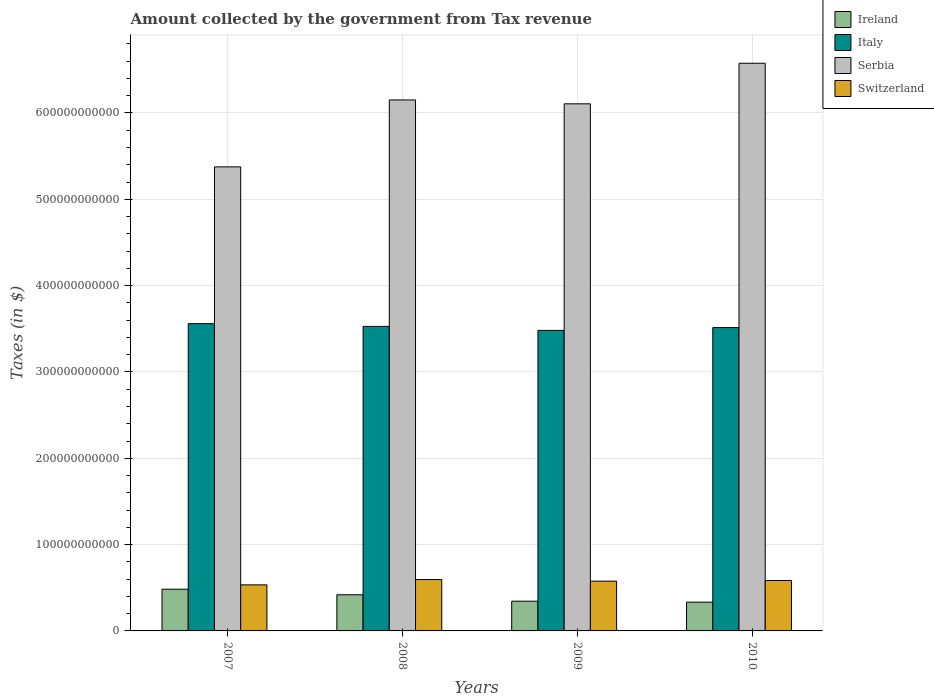How many different coloured bars are there?
Your answer should be very brief. 4. How many groups of bars are there?
Ensure brevity in your answer.  4. How many bars are there on the 4th tick from the left?
Provide a short and direct response. 4. How many bars are there on the 1st tick from the right?
Give a very brief answer. 4. What is the label of the 2nd group of bars from the left?
Your answer should be compact. 2008. What is the amount collected by the government from tax revenue in Switzerland in 2007?
Your answer should be compact. 5.34e+1. Across all years, what is the maximum amount collected by the government from tax revenue in Serbia?
Ensure brevity in your answer.  6.58e+11. Across all years, what is the minimum amount collected by the government from tax revenue in Serbia?
Your answer should be very brief. 5.38e+11. What is the total amount collected by the government from tax revenue in Switzerland in the graph?
Make the answer very short. 2.29e+11. What is the difference between the amount collected by the government from tax revenue in Italy in 2007 and that in 2009?
Keep it short and to the point. 7.78e+09. What is the difference between the amount collected by the government from tax revenue in Switzerland in 2008 and the amount collected by the government from tax revenue in Italy in 2009?
Your answer should be compact. -2.89e+11. What is the average amount collected by the government from tax revenue in Switzerland per year?
Your answer should be compact. 5.72e+1. In the year 2008, what is the difference between the amount collected by the government from tax revenue in Serbia and amount collected by the government from tax revenue in Italy?
Your answer should be very brief. 2.62e+11. In how many years, is the amount collected by the government from tax revenue in Switzerland greater than 380000000000 $?
Provide a succinct answer. 0. What is the ratio of the amount collected by the government from tax revenue in Switzerland in 2008 to that in 2010?
Ensure brevity in your answer.  1.02. What is the difference between the highest and the second highest amount collected by the government from tax revenue in Italy?
Ensure brevity in your answer.  3.18e+09. What is the difference between the highest and the lowest amount collected by the government from tax revenue in Serbia?
Provide a short and direct response. 1.20e+11. In how many years, is the amount collected by the government from tax revenue in Ireland greater than the average amount collected by the government from tax revenue in Ireland taken over all years?
Provide a short and direct response. 2. What does the 2nd bar from the left in 2007 represents?
Offer a very short reply. Italy. What does the 1st bar from the right in 2008 represents?
Make the answer very short. Switzerland. How many bars are there?
Give a very brief answer. 16. How many years are there in the graph?
Your answer should be very brief. 4. What is the difference between two consecutive major ticks on the Y-axis?
Provide a short and direct response. 1.00e+11. Where does the legend appear in the graph?
Ensure brevity in your answer.  Top right. What is the title of the graph?
Give a very brief answer. Amount collected by the government from Tax revenue. What is the label or title of the X-axis?
Your response must be concise. Years. What is the label or title of the Y-axis?
Your response must be concise. Taxes (in $). What is the Taxes (in $) of Ireland in 2007?
Your answer should be compact. 4.83e+1. What is the Taxes (in $) of Italy in 2007?
Keep it short and to the point. 3.56e+11. What is the Taxes (in $) in Serbia in 2007?
Make the answer very short. 5.38e+11. What is the Taxes (in $) of Switzerland in 2007?
Keep it short and to the point. 5.34e+1. What is the Taxes (in $) in Ireland in 2008?
Offer a terse response. 4.19e+1. What is the Taxes (in $) of Italy in 2008?
Ensure brevity in your answer.  3.53e+11. What is the Taxes (in $) of Serbia in 2008?
Provide a short and direct response. 6.15e+11. What is the Taxes (in $) of Switzerland in 2008?
Provide a succinct answer. 5.95e+1. What is the Taxes (in $) of Ireland in 2009?
Provide a short and direct response. 3.45e+1. What is the Taxes (in $) in Italy in 2009?
Make the answer very short. 3.48e+11. What is the Taxes (in $) of Serbia in 2009?
Make the answer very short. 6.11e+11. What is the Taxes (in $) of Switzerland in 2009?
Provide a succinct answer. 5.77e+1. What is the Taxes (in $) of Ireland in 2010?
Provide a short and direct response. 3.33e+1. What is the Taxes (in $) of Italy in 2010?
Provide a succinct answer. 3.51e+11. What is the Taxes (in $) in Serbia in 2010?
Your response must be concise. 6.58e+11. What is the Taxes (in $) in Switzerland in 2010?
Offer a terse response. 5.84e+1. Across all years, what is the maximum Taxes (in $) of Ireland?
Provide a short and direct response. 4.83e+1. Across all years, what is the maximum Taxes (in $) in Italy?
Your answer should be very brief. 3.56e+11. Across all years, what is the maximum Taxes (in $) in Serbia?
Offer a very short reply. 6.58e+11. Across all years, what is the maximum Taxes (in $) in Switzerland?
Provide a short and direct response. 5.95e+1. Across all years, what is the minimum Taxes (in $) in Ireland?
Your response must be concise. 3.33e+1. Across all years, what is the minimum Taxes (in $) in Italy?
Your answer should be compact. 3.48e+11. Across all years, what is the minimum Taxes (in $) in Serbia?
Make the answer very short. 5.38e+11. Across all years, what is the minimum Taxes (in $) in Switzerland?
Your answer should be very brief. 5.34e+1. What is the total Taxes (in $) of Ireland in the graph?
Make the answer very short. 1.58e+11. What is the total Taxes (in $) of Italy in the graph?
Keep it short and to the point. 1.41e+12. What is the total Taxes (in $) in Serbia in the graph?
Your answer should be compact. 2.42e+12. What is the total Taxes (in $) of Switzerland in the graph?
Give a very brief answer. 2.29e+11. What is the difference between the Taxes (in $) in Ireland in 2007 and that in 2008?
Keep it short and to the point. 6.43e+09. What is the difference between the Taxes (in $) of Italy in 2007 and that in 2008?
Ensure brevity in your answer.  3.18e+09. What is the difference between the Taxes (in $) of Serbia in 2007 and that in 2008?
Offer a very short reply. -7.75e+1. What is the difference between the Taxes (in $) of Switzerland in 2007 and that in 2008?
Your answer should be compact. -6.15e+09. What is the difference between the Taxes (in $) of Ireland in 2007 and that in 2009?
Your answer should be very brief. 1.39e+1. What is the difference between the Taxes (in $) in Italy in 2007 and that in 2009?
Offer a terse response. 7.78e+09. What is the difference between the Taxes (in $) in Serbia in 2007 and that in 2009?
Your answer should be compact. -7.30e+1. What is the difference between the Taxes (in $) of Switzerland in 2007 and that in 2009?
Your answer should be compact. -4.30e+09. What is the difference between the Taxes (in $) of Ireland in 2007 and that in 2010?
Your answer should be compact. 1.50e+1. What is the difference between the Taxes (in $) in Italy in 2007 and that in 2010?
Your answer should be very brief. 4.54e+09. What is the difference between the Taxes (in $) in Serbia in 2007 and that in 2010?
Make the answer very short. -1.20e+11. What is the difference between the Taxes (in $) in Switzerland in 2007 and that in 2010?
Offer a very short reply. -5.05e+09. What is the difference between the Taxes (in $) in Ireland in 2008 and that in 2009?
Provide a succinct answer. 7.44e+09. What is the difference between the Taxes (in $) of Italy in 2008 and that in 2009?
Your answer should be compact. 4.60e+09. What is the difference between the Taxes (in $) of Serbia in 2008 and that in 2009?
Your answer should be compact. 4.50e+09. What is the difference between the Taxes (in $) of Switzerland in 2008 and that in 2009?
Provide a succinct answer. 1.85e+09. What is the difference between the Taxes (in $) of Ireland in 2008 and that in 2010?
Offer a terse response. 8.56e+09. What is the difference between the Taxes (in $) of Italy in 2008 and that in 2010?
Your response must be concise. 1.37e+09. What is the difference between the Taxes (in $) in Serbia in 2008 and that in 2010?
Provide a short and direct response. -4.25e+1. What is the difference between the Taxes (in $) of Switzerland in 2008 and that in 2010?
Provide a short and direct response. 1.10e+09. What is the difference between the Taxes (in $) in Ireland in 2009 and that in 2010?
Ensure brevity in your answer.  1.13e+09. What is the difference between the Taxes (in $) of Italy in 2009 and that in 2010?
Offer a very short reply. -3.24e+09. What is the difference between the Taxes (in $) of Serbia in 2009 and that in 2010?
Your response must be concise. -4.70e+1. What is the difference between the Taxes (in $) of Switzerland in 2009 and that in 2010?
Make the answer very short. -7.46e+08. What is the difference between the Taxes (in $) of Ireland in 2007 and the Taxes (in $) of Italy in 2008?
Your answer should be very brief. -3.04e+11. What is the difference between the Taxes (in $) of Ireland in 2007 and the Taxes (in $) of Serbia in 2008?
Provide a succinct answer. -5.67e+11. What is the difference between the Taxes (in $) in Ireland in 2007 and the Taxes (in $) in Switzerland in 2008?
Give a very brief answer. -1.12e+1. What is the difference between the Taxes (in $) of Italy in 2007 and the Taxes (in $) of Serbia in 2008?
Ensure brevity in your answer.  -2.59e+11. What is the difference between the Taxes (in $) in Italy in 2007 and the Taxes (in $) in Switzerland in 2008?
Provide a short and direct response. 2.96e+11. What is the difference between the Taxes (in $) in Serbia in 2007 and the Taxes (in $) in Switzerland in 2008?
Make the answer very short. 4.78e+11. What is the difference between the Taxes (in $) in Ireland in 2007 and the Taxes (in $) in Italy in 2009?
Your answer should be very brief. -3.00e+11. What is the difference between the Taxes (in $) of Ireland in 2007 and the Taxes (in $) of Serbia in 2009?
Provide a short and direct response. -5.62e+11. What is the difference between the Taxes (in $) of Ireland in 2007 and the Taxes (in $) of Switzerland in 2009?
Offer a very short reply. -9.33e+09. What is the difference between the Taxes (in $) of Italy in 2007 and the Taxes (in $) of Serbia in 2009?
Ensure brevity in your answer.  -2.55e+11. What is the difference between the Taxes (in $) in Italy in 2007 and the Taxes (in $) in Switzerland in 2009?
Your answer should be very brief. 2.98e+11. What is the difference between the Taxes (in $) of Serbia in 2007 and the Taxes (in $) of Switzerland in 2009?
Ensure brevity in your answer.  4.80e+11. What is the difference between the Taxes (in $) in Ireland in 2007 and the Taxes (in $) in Italy in 2010?
Offer a terse response. -3.03e+11. What is the difference between the Taxes (in $) in Ireland in 2007 and the Taxes (in $) in Serbia in 2010?
Keep it short and to the point. -6.09e+11. What is the difference between the Taxes (in $) in Ireland in 2007 and the Taxes (in $) in Switzerland in 2010?
Provide a succinct answer. -1.01e+1. What is the difference between the Taxes (in $) in Italy in 2007 and the Taxes (in $) in Serbia in 2010?
Offer a terse response. -3.02e+11. What is the difference between the Taxes (in $) of Italy in 2007 and the Taxes (in $) of Switzerland in 2010?
Offer a very short reply. 2.98e+11. What is the difference between the Taxes (in $) in Serbia in 2007 and the Taxes (in $) in Switzerland in 2010?
Your answer should be compact. 4.79e+11. What is the difference between the Taxes (in $) of Ireland in 2008 and the Taxes (in $) of Italy in 2009?
Offer a very short reply. -3.06e+11. What is the difference between the Taxes (in $) in Ireland in 2008 and the Taxes (in $) in Serbia in 2009?
Ensure brevity in your answer.  -5.69e+11. What is the difference between the Taxes (in $) in Ireland in 2008 and the Taxes (in $) in Switzerland in 2009?
Provide a short and direct response. -1.58e+1. What is the difference between the Taxes (in $) of Italy in 2008 and the Taxes (in $) of Serbia in 2009?
Offer a terse response. -2.58e+11. What is the difference between the Taxes (in $) of Italy in 2008 and the Taxes (in $) of Switzerland in 2009?
Your response must be concise. 2.95e+11. What is the difference between the Taxes (in $) in Serbia in 2008 and the Taxes (in $) in Switzerland in 2009?
Your answer should be very brief. 5.57e+11. What is the difference between the Taxes (in $) in Ireland in 2008 and the Taxes (in $) in Italy in 2010?
Your response must be concise. -3.09e+11. What is the difference between the Taxes (in $) in Ireland in 2008 and the Taxes (in $) in Serbia in 2010?
Provide a short and direct response. -6.16e+11. What is the difference between the Taxes (in $) of Ireland in 2008 and the Taxes (in $) of Switzerland in 2010?
Provide a short and direct response. -1.65e+1. What is the difference between the Taxes (in $) of Italy in 2008 and the Taxes (in $) of Serbia in 2010?
Make the answer very short. -3.05e+11. What is the difference between the Taxes (in $) of Italy in 2008 and the Taxes (in $) of Switzerland in 2010?
Keep it short and to the point. 2.94e+11. What is the difference between the Taxes (in $) of Serbia in 2008 and the Taxes (in $) of Switzerland in 2010?
Offer a very short reply. 5.57e+11. What is the difference between the Taxes (in $) in Ireland in 2009 and the Taxes (in $) in Italy in 2010?
Provide a short and direct response. -3.17e+11. What is the difference between the Taxes (in $) in Ireland in 2009 and the Taxes (in $) in Serbia in 2010?
Offer a very short reply. -6.23e+11. What is the difference between the Taxes (in $) of Ireland in 2009 and the Taxes (in $) of Switzerland in 2010?
Ensure brevity in your answer.  -2.39e+1. What is the difference between the Taxes (in $) of Italy in 2009 and the Taxes (in $) of Serbia in 2010?
Your response must be concise. -3.09e+11. What is the difference between the Taxes (in $) in Italy in 2009 and the Taxes (in $) in Switzerland in 2010?
Offer a terse response. 2.90e+11. What is the difference between the Taxes (in $) in Serbia in 2009 and the Taxes (in $) in Switzerland in 2010?
Give a very brief answer. 5.52e+11. What is the average Taxes (in $) in Ireland per year?
Provide a succinct answer. 3.95e+1. What is the average Taxes (in $) of Italy per year?
Give a very brief answer. 3.52e+11. What is the average Taxes (in $) of Serbia per year?
Offer a very short reply. 6.05e+11. What is the average Taxes (in $) of Switzerland per year?
Provide a short and direct response. 5.72e+1. In the year 2007, what is the difference between the Taxes (in $) in Ireland and Taxes (in $) in Italy?
Make the answer very short. -3.08e+11. In the year 2007, what is the difference between the Taxes (in $) in Ireland and Taxes (in $) in Serbia?
Ensure brevity in your answer.  -4.89e+11. In the year 2007, what is the difference between the Taxes (in $) in Ireland and Taxes (in $) in Switzerland?
Provide a short and direct response. -5.03e+09. In the year 2007, what is the difference between the Taxes (in $) of Italy and Taxes (in $) of Serbia?
Keep it short and to the point. -1.82e+11. In the year 2007, what is the difference between the Taxes (in $) of Italy and Taxes (in $) of Switzerland?
Offer a very short reply. 3.03e+11. In the year 2007, what is the difference between the Taxes (in $) of Serbia and Taxes (in $) of Switzerland?
Your answer should be compact. 4.84e+11. In the year 2008, what is the difference between the Taxes (in $) in Ireland and Taxes (in $) in Italy?
Offer a terse response. -3.11e+11. In the year 2008, what is the difference between the Taxes (in $) in Ireland and Taxes (in $) in Serbia?
Give a very brief answer. -5.73e+11. In the year 2008, what is the difference between the Taxes (in $) of Ireland and Taxes (in $) of Switzerland?
Give a very brief answer. -1.76e+1. In the year 2008, what is the difference between the Taxes (in $) of Italy and Taxes (in $) of Serbia?
Offer a very short reply. -2.62e+11. In the year 2008, what is the difference between the Taxes (in $) of Italy and Taxes (in $) of Switzerland?
Ensure brevity in your answer.  2.93e+11. In the year 2008, what is the difference between the Taxes (in $) of Serbia and Taxes (in $) of Switzerland?
Your answer should be very brief. 5.56e+11. In the year 2009, what is the difference between the Taxes (in $) of Ireland and Taxes (in $) of Italy?
Provide a succinct answer. -3.14e+11. In the year 2009, what is the difference between the Taxes (in $) in Ireland and Taxes (in $) in Serbia?
Provide a short and direct response. -5.76e+11. In the year 2009, what is the difference between the Taxes (in $) in Ireland and Taxes (in $) in Switzerland?
Keep it short and to the point. -2.32e+1. In the year 2009, what is the difference between the Taxes (in $) in Italy and Taxes (in $) in Serbia?
Provide a short and direct response. -2.62e+11. In the year 2009, what is the difference between the Taxes (in $) in Italy and Taxes (in $) in Switzerland?
Provide a short and direct response. 2.90e+11. In the year 2009, what is the difference between the Taxes (in $) of Serbia and Taxes (in $) of Switzerland?
Ensure brevity in your answer.  5.53e+11. In the year 2010, what is the difference between the Taxes (in $) in Ireland and Taxes (in $) in Italy?
Provide a succinct answer. -3.18e+11. In the year 2010, what is the difference between the Taxes (in $) in Ireland and Taxes (in $) in Serbia?
Provide a succinct answer. -6.24e+11. In the year 2010, what is the difference between the Taxes (in $) in Ireland and Taxes (in $) in Switzerland?
Keep it short and to the point. -2.51e+1. In the year 2010, what is the difference between the Taxes (in $) in Italy and Taxes (in $) in Serbia?
Your response must be concise. -3.06e+11. In the year 2010, what is the difference between the Taxes (in $) in Italy and Taxes (in $) in Switzerland?
Keep it short and to the point. 2.93e+11. In the year 2010, what is the difference between the Taxes (in $) of Serbia and Taxes (in $) of Switzerland?
Provide a short and direct response. 5.99e+11. What is the ratio of the Taxes (in $) in Ireland in 2007 to that in 2008?
Keep it short and to the point. 1.15. What is the ratio of the Taxes (in $) of Italy in 2007 to that in 2008?
Make the answer very short. 1.01. What is the ratio of the Taxes (in $) in Serbia in 2007 to that in 2008?
Your answer should be very brief. 0.87. What is the ratio of the Taxes (in $) of Switzerland in 2007 to that in 2008?
Give a very brief answer. 0.9. What is the ratio of the Taxes (in $) of Ireland in 2007 to that in 2009?
Provide a short and direct response. 1.4. What is the ratio of the Taxes (in $) of Italy in 2007 to that in 2009?
Your answer should be compact. 1.02. What is the ratio of the Taxes (in $) of Serbia in 2007 to that in 2009?
Give a very brief answer. 0.88. What is the ratio of the Taxes (in $) of Switzerland in 2007 to that in 2009?
Provide a succinct answer. 0.93. What is the ratio of the Taxes (in $) in Ireland in 2007 to that in 2010?
Make the answer very short. 1.45. What is the ratio of the Taxes (in $) in Italy in 2007 to that in 2010?
Offer a terse response. 1.01. What is the ratio of the Taxes (in $) in Serbia in 2007 to that in 2010?
Ensure brevity in your answer.  0.82. What is the ratio of the Taxes (in $) of Switzerland in 2007 to that in 2010?
Offer a terse response. 0.91. What is the ratio of the Taxes (in $) of Ireland in 2008 to that in 2009?
Provide a short and direct response. 1.22. What is the ratio of the Taxes (in $) of Italy in 2008 to that in 2009?
Your answer should be very brief. 1.01. What is the ratio of the Taxes (in $) in Serbia in 2008 to that in 2009?
Your answer should be very brief. 1.01. What is the ratio of the Taxes (in $) in Switzerland in 2008 to that in 2009?
Ensure brevity in your answer.  1.03. What is the ratio of the Taxes (in $) in Ireland in 2008 to that in 2010?
Your answer should be very brief. 1.26. What is the ratio of the Taxes (in $) in Serbia in 2008 to that in 2010?
Make the answer very short. 0.94. What is the ratio of the Taxes (in $) of Switzerland in 2008 to that in 2010?
Provide a short and direct response. 1.02. What is the ratio of the Taxes (in $) of Ireland in 2009 to that in 2010?
Offer a terse response. 1.03. What is the ratio of the Taxes (in $) of Italy in 2009 to that in 2010?
Provide a succinct answer. 0.99. What is the ratio of the Taxes (in $) in Serbia in 2009 to that in 2010?
Make the answer very short. 0.93. What is the ratio of the Taxes (in $) of Switzerland in 2009 to that in 2010?
Your answer should be very brief. 0.99. What is the difference between the highest and the second highest Taxes (in $) in Ireland?
Give a very brief answer. 6.43e+09. What is the difference between the highest and the second highest Taxes (in $) of Italy?
Provide a succinct answer. 3.18e+09. What is the difference between the highest and the second highest Taxes (in $) in Serbia?
Your answer should be compact. 4.25e+1. What is the difference between the highest and the second highest Taxes (in $) of Switzerland?
Provide a succinct answer. 1.10e+09. What is the difference between the highest and the lowest Taxes (in $) of Ireland?
Make the answer very short. 1.50e+1. What is the difference between the highest and the lowest Taxes (in $) in Italy?
Keep it short and to the point. 7.78e+09. What is the difference between the highest and the lowest Taxes (in $) in Serbia?
Your answer should be compact. 1.20e+11. What is the difference between the highest and the lowest Taxes (in $) in Switzerland?
Make the answer very short. 6.15e+09. 